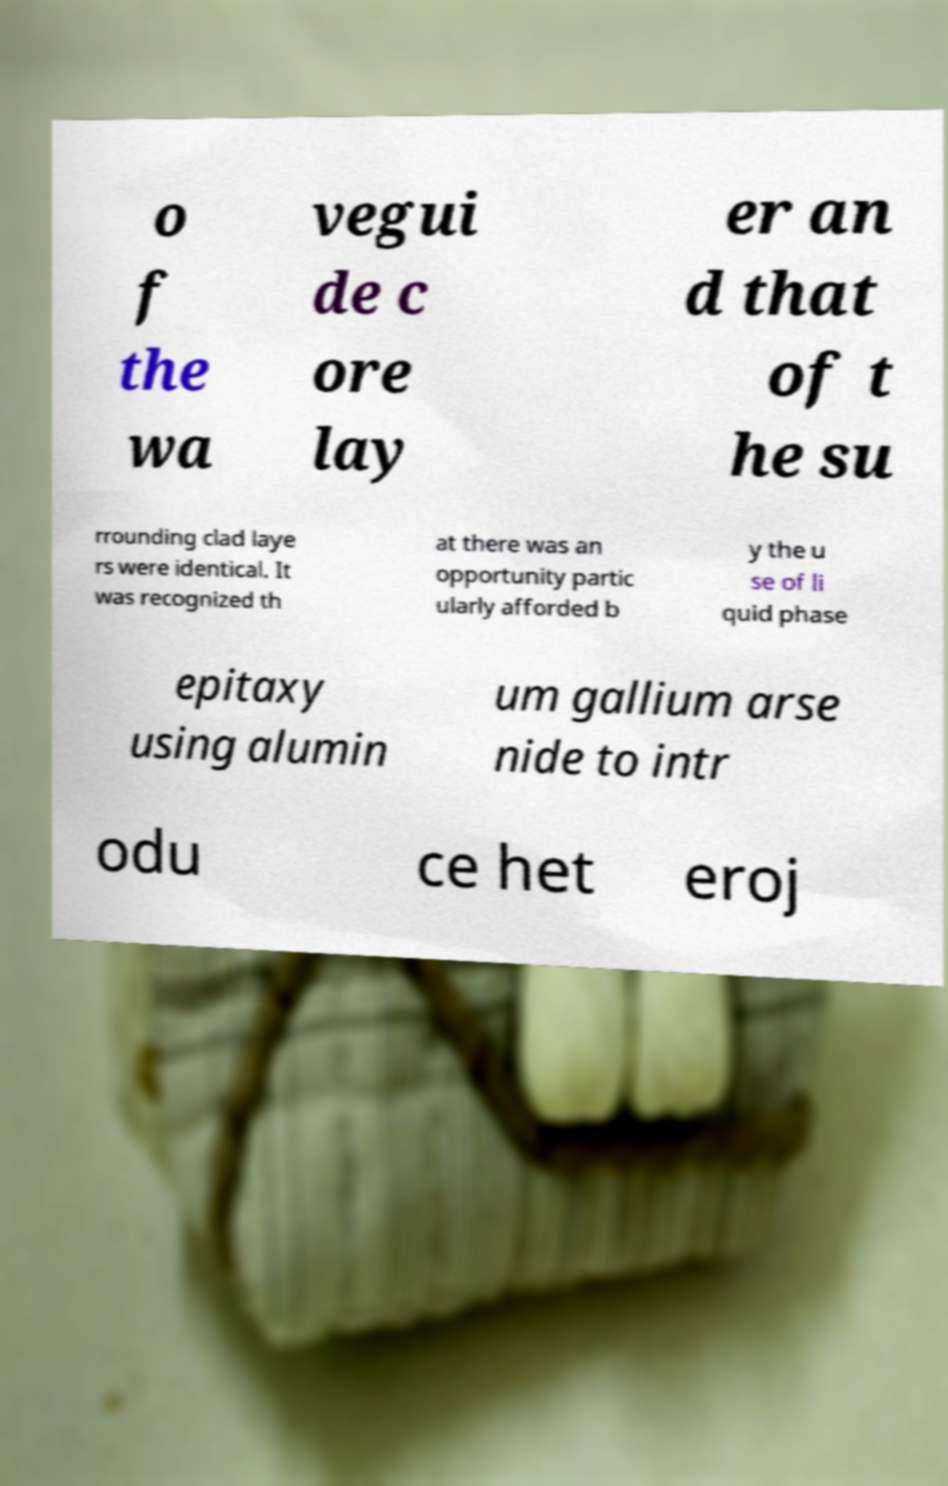There's text embedded in this image that I need extracted. Can you transcribe it verbatim? o f the wa vegui de c ore lay er an d that of t he su rrounding clad laye rs were identical. It was recognized th at there was an opportunity partic ularly afforded b y the u se of li quid phase epitaxy using alumin um gallium arse nide to intr odu ce het eroj 